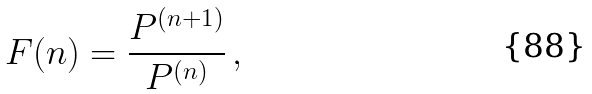Convert formula to latex. <formula><loc_0><loc_0><loc_500><loc_500>F ( n ) = \frac { P ^ { ( n + 1 ) } } { P ^ { ( n ) } } \, ,</formula> 